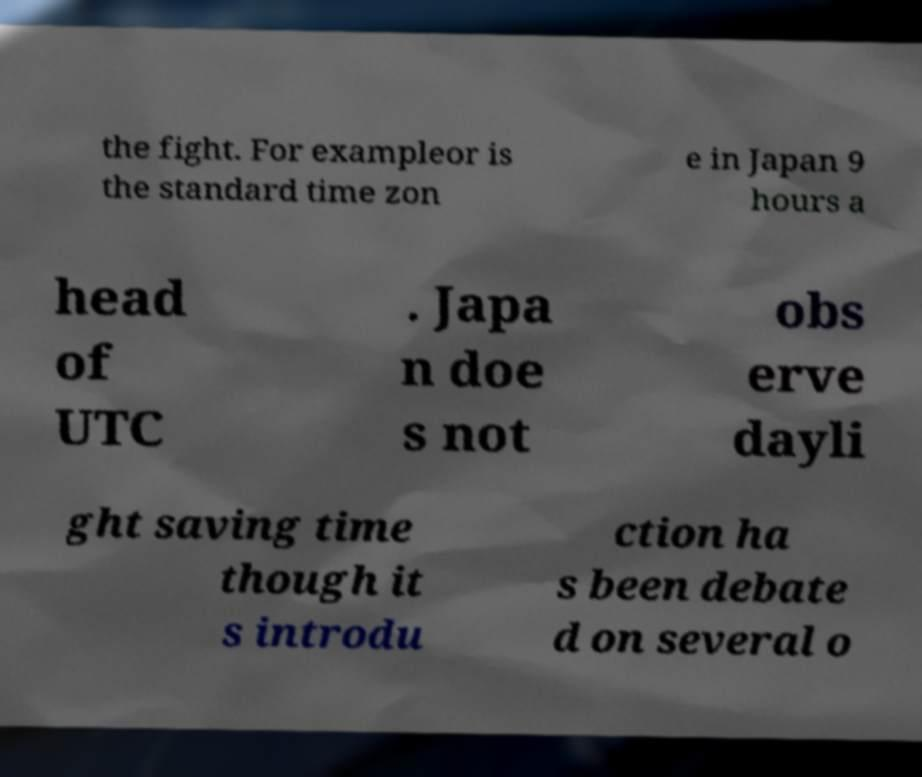What messages or text are displayed in this image? I need them in a readable, typed format. the fight. For exampleor is the standard time zon e in Japan 9 hours a head of UTC . Japa n doe s not obs erve dayli ght saving time though it s introdu ction ha s been debate d on several o 